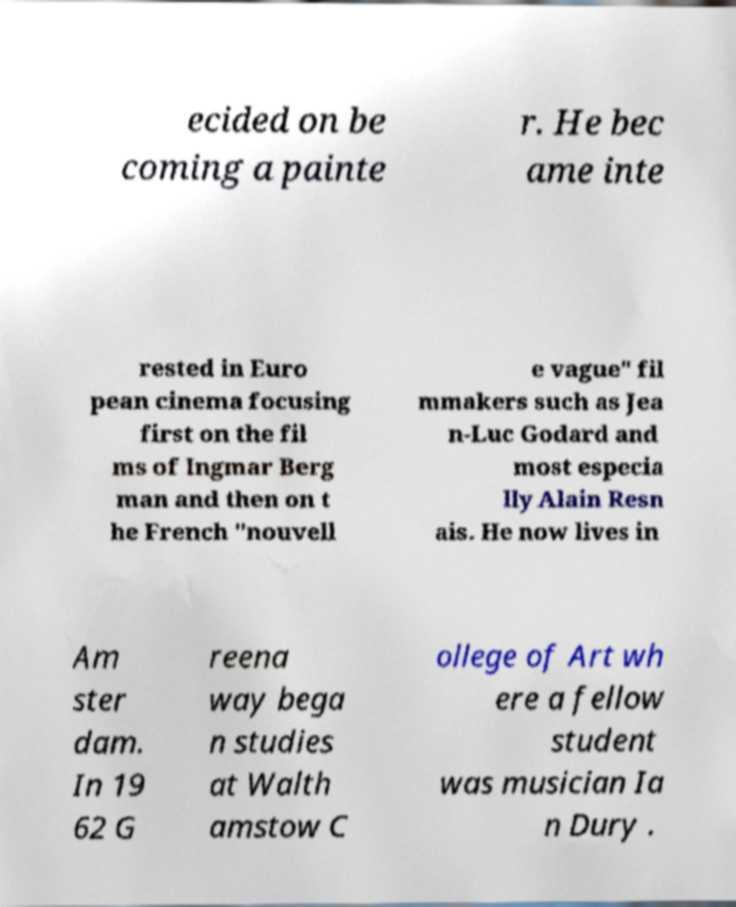Could you assist in decoding the text presented in this image and type it out clearly? ecided on be coming a painte r. He bec ame inte rested in Euro pean cinema focusing first on the fil ms of Ingmar Berg man and then on t he French "nouvell e vague" fil mmakers such as Jea n-Luc Godard and most especia lly Alain Resn ais. He now lives in Am ster dam. In 19 62 G reena way bega n studies at Walth amstow C ollege of Art wh ere a fellow student was musician Ia n Dury . 